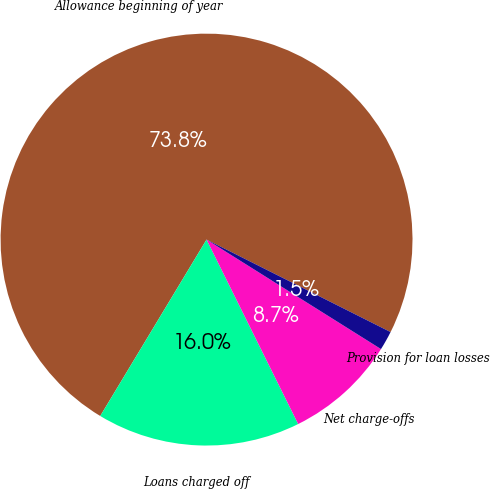Convert chart. <chart><loc_0><loc_0><loc_500><loc_500><pie_chart><fcel>Allowance beginning of year<fcel>Loans charged off<fcel>Net charge-offs<fcel>Provision for loan losses<nl><fcel>73.78%<fcel>15.97%<fcel>8.74%<fcel>1.51%<nl></chart> 